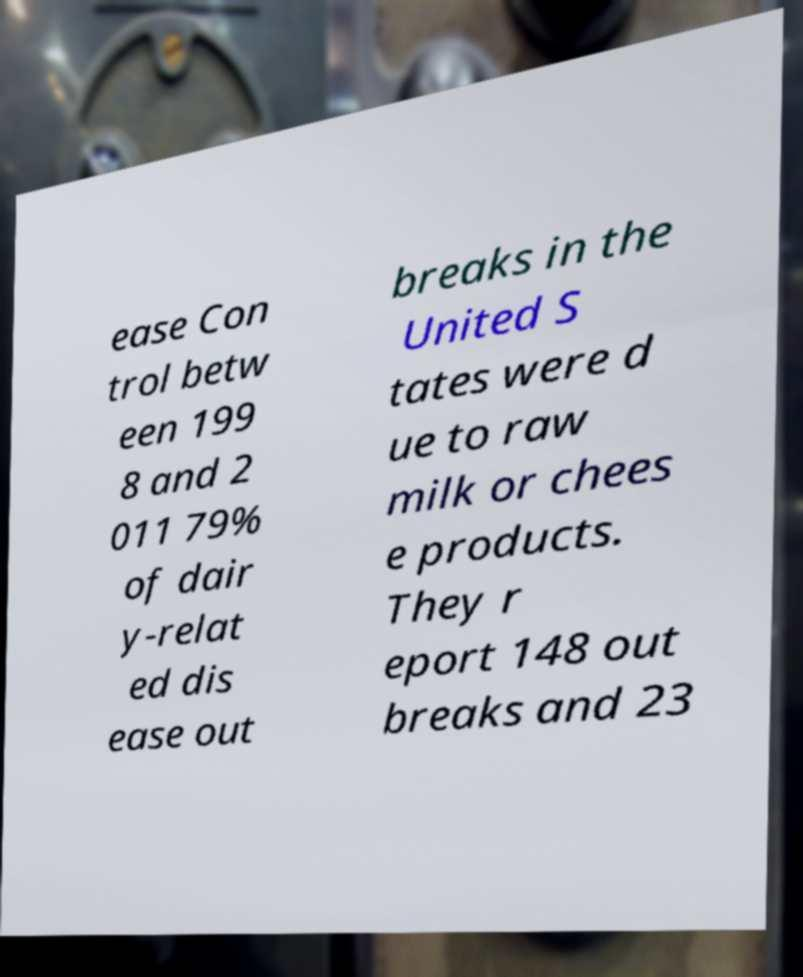Could you assist in decoding the text presented in this image and type it out clearly? ease Con trol betw een 199 8 and 2 011 79% of dair y-relat ed dis ease out breaks in the United S tates were d ue to raw milk or chees e products. They r eport 148 out breaks and 23 